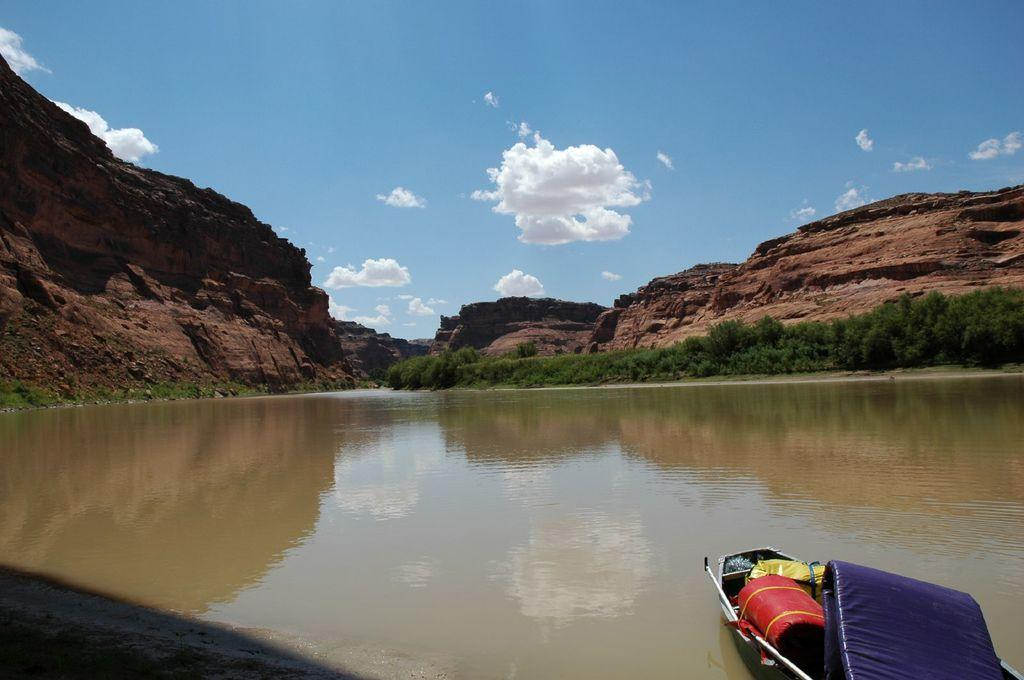What is the main subject of the image? The main subject of the image is a boat. Where is the boat located? The boat is on water. What can be seen in the background of the image? There are rocks, trees, and the sky visible in the background of the image. What is the condition of the sky in the image? The sky is visible in the background of the image, and clouds are present. What type of pen is the lawyer using to answer questions in the image? There is no lawyer or pen present in the image; it features a boat on water with a background of rocks, trees, and the sky. 